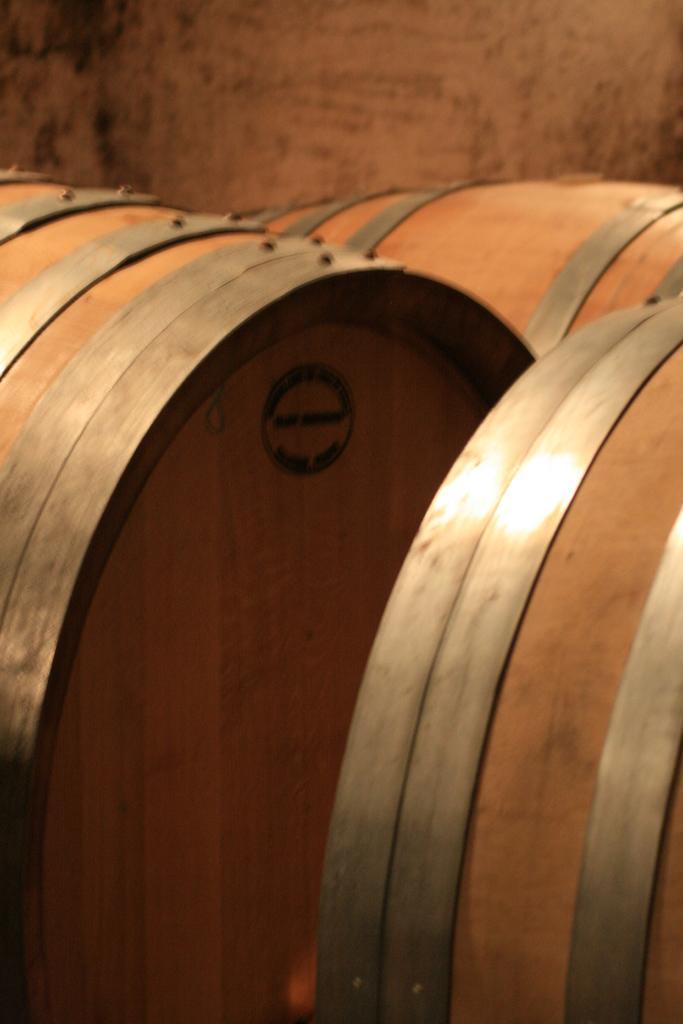Describe this image in one or two sentences. In this picture we can see barrels. In the background of the image we can see wall. 